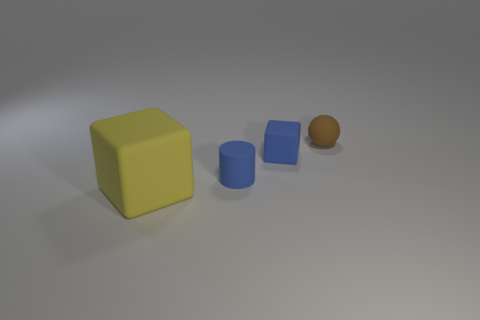Do the tiny blue cube and the object that is in front of the small blue cylinder have the same material?
Offer a very short reply. Yes. How many other yellow rubber objects have the same shape as the yellow object?
Your response must be concise. 0. There is a small object that is the same color as the small rubber cylinder; what is it made of?
Give a very brief answer. Rubber. How many rubber cubes are there?
Offer a very short reply. 2. There is a big yellow thing; is its shape the same as the blue rubber thing behind the small rubber cylinder?
Make the answer very short. Yes. What number of things are small blue cubes or rubber things in front of the brown matte ball?
Provide a short and direct response. 3. Is the shape of the small blue matte object behind the tiny blue rubber cylinder the same as  the big thing?
Provide a succinct answer. Yes. Is there any other thing that is the same size as the yellow thing?
Provide a succinct answer. No. Are there fewer big cubes behind the blue matte block than brown matte things that are behind the yellow block?
Keep it short and to the point. Yes. What number of other objects are the same shape as the tiny brown rubber object?
Make the answer very short. 0. 